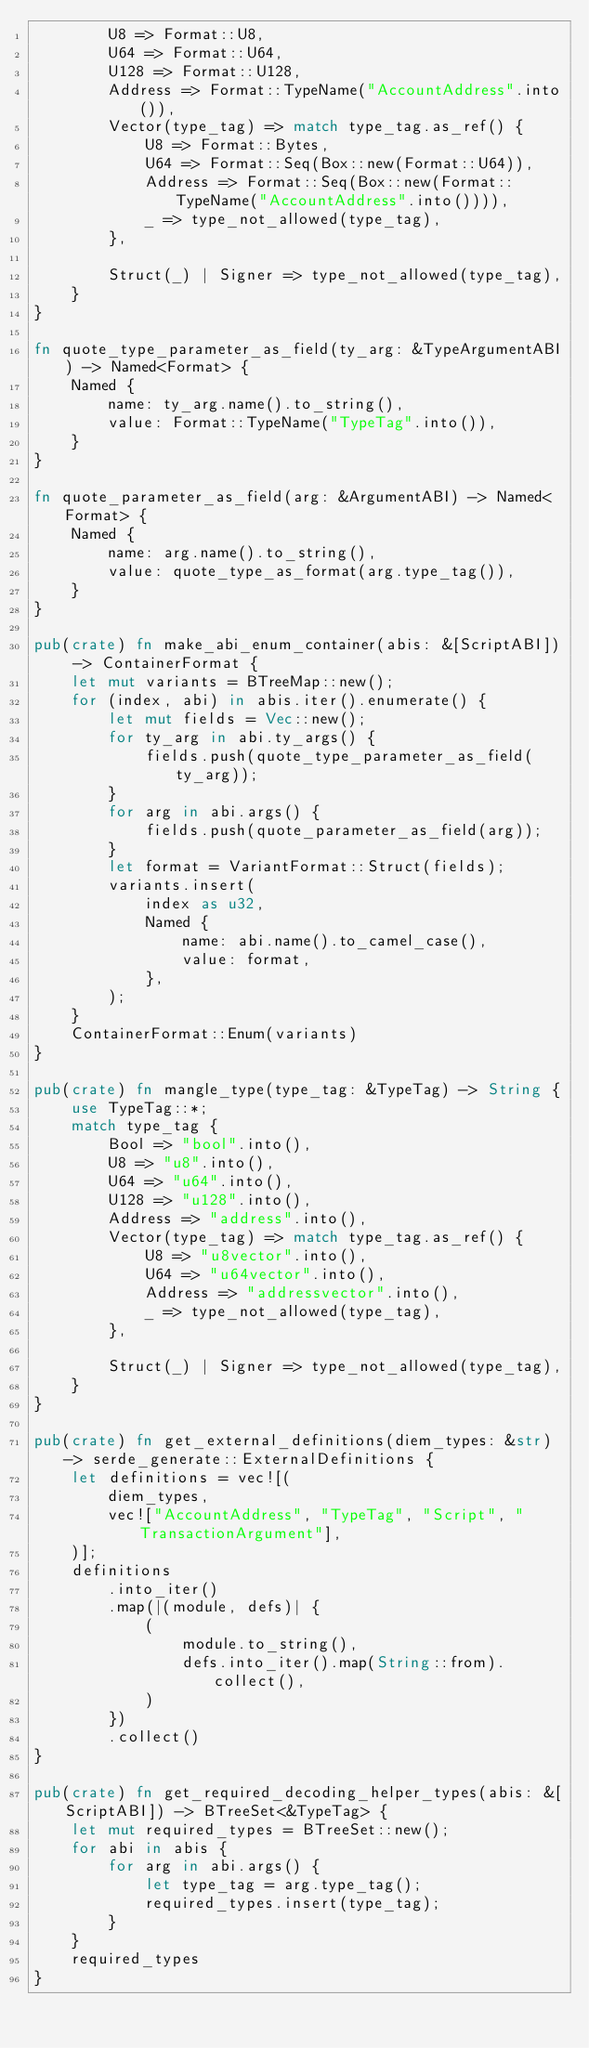Convert code to text. <code><loc_0><loc_0><loc_500><loc_500><_Rust_>        U8 => Format::U8,
        U64 => Format::U64,
        U128 => Format::U128,
        Address => Format::TypeName("AccountAddress".into()),
        Vector(type_tag) => match type_tag.as_ref() {
            U8 => Format::Bytes,
            U64 => Format::Seq(Box::new(Format::U64)),
            Address => Format::Seq(Box::new(Format::TypeName("AccountAddress".into()))),
            _ => type_not_allowed(type_tag),
        },

        Struct(_) | Signer => type_not_allowed(type_tag),
    }
}

fn quote_type_parameter_as_field(ty_arg: &TypeArgumentABI) -> Named<Format> {
    Named {
        name: ty_arg.name().to_string(),
        value: Format::TypeName("TypeTag".into()),
    }
}

fn quote_parameter_as_field(arg: &ArgumentABI) -> Named<Format> {
    Named {
        name: arg.name().to_string(),
        value: quote_type_as_format(arg.type_tag()),
    }
}

pub(crate) fn make_abi_enum_container(abis: &[ScriptABI]) -> ContainerFormat {
    let mut variants = BTreeMap::new();
    for (index, abi) in abis.iter().enumerate() {
        let mut fields = Vec::new();
        for ty_arg in abi.ty_args() {
            fields.push(quote_type_parameter_as_field(ty_arg));
        }
        for arg in abi.args() {
            fields.push(quote_parameter_as_field(arg));
        }
        let format = VariantFormat::Struct(fields);
        variants.insert(
            index as u32,
            Named {
                name: abi.name().to_camel_case(),
                value: format,
            },
        );
    }
    ContainerFormat::Enum(variants)
}

pub(crate) fn mangle_type(type_tag: &TypeTag) -> String {
    use TypeTag::*;
    match type_tag {
        Bool => "bool".into(),
        U8 => "u8".into(),
        U64 => "u64".into(),
        U128 => "u128".into(),
        Address => "address".into(),
        Vector(type_tag) => match type_tag.as_ref() {
            U8 => "u8vector".into(),
            U64 => "u64vector".into(),
            Address => "addressvector".into(),
            _ => type_not_allowed(type_tag),
        },

        Struct(_) | Signer => type_not_allowed(type_tag),
    }
}

pub(crate) fn get_external_definitions(diem_types: &str) -> serde_generate::ExternalDefinitions {
    let definitions = vec![(
        diem_types,
        vec!["AccountAddress", "TypeTag", "Script", "TransactionArgument"],
    )];
    definitions
        .into_iter()
        .map(|(module, defs)| {
            (
                module.to_string(),
                defs.into_iter().map(String::from).collect(),
            )
        })
        .collect()
}

pub(crate) fn get_required_decoding_helper_types(abis: &[ScriptABI]) -> BTreeSet<&TypeTag> {
    let mut required_types = BTreeSet::new();
    for abi in abis {
        for arg in abi.args() {
            let type_tag = arg.type_tag();
            required_types.insert(type_tag);
        }
    }
    required_types
}
</code> 